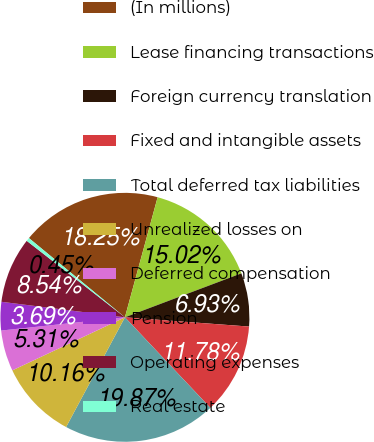Convert chart to OTSL. <chart><loc_0><loc_0><loc_500><loc_500><pie_chart><fcel>(In millions)<fcel>Lease financing transactions<fcel>Foreign currency translation<fcel>Fixed and intangible assets<fcel>Total deferred tax liabilities<fcel>Unrealized losses on<fcel>Deferred compensation<fcel>Pension<fcel>Operating expenses<fcel>Real estate<nl><fcel>18.25%<fcel>15.02%<fcel>6.93%<fcel>11.78%<fcel>19.87%<fcel>10.16%<fcel>5.31%<fcel>3.69%<fcel>8.54%<fcel>0.45%<nl></chart> 